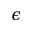<formula> <loc_0><loc_0><loc_500><loc_500>\epsilon</formula> 